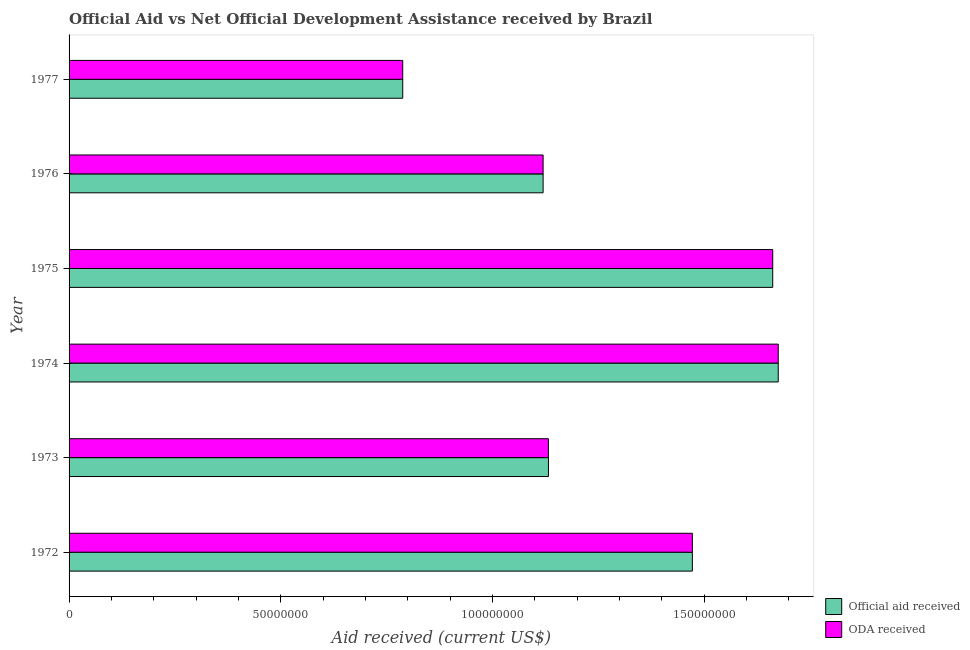How many groups of bars are there?
Provide a succinct answer. 6. Are the number of bars on each tick of the Y-axis equal?
Keep it short and to the point. Yes. How many bars are there on the 3rd tick from the bottom?
Keep it short and to the point. 2. In how many cases, is the number of bars for a given year not equal to the number of legend labels?
Your answer should be compact. 0. What is the official aid received in 1977?
Your answer should be very brief. 7.88e+07. Across all years, what is the maximum oda received?
Your answer should be compact. 1.67e+08. Across all years, what is the minimum official aid received?
Ensure brevity in your answer.  7.88e+07. In which year was the oda received maximum?
Give a very brief answer. 1974. What is the total oda received in the graph?
Offer a terse response. 7.85e+08. What is the difference between the oda received in 1972 and that in 1976?
Provide a succinct answer. 3.52e+07. What is the difference between the oda received in 1976 and the official aid received in 1974?
Offer a very short reply. -5.55e+07. What is the average official aid received per year?
Ensure brevity in your answer.  1.31e+08. What is the ratio of the official aid received in 1972 to that in 1977?
Keep it short and to the point. 1.87. Is the official aid received in 1974 less than that in 1975?
Provide a short and direct response. No. What is the difference between the highest and the second highest oda received?
Keep it short and to the point. 1.30e+06. What is the difference between the highest and the lowest official aid received?
Keep it short and to the point. 8.87e+07. In how many years, is the official aid received greater than the average official aid received taken over all years?
Make the answer very short. 3. What does the 2nd bar from the top in 1975 represents?
Give a very brief answer. Official aid received. What does the 1st bar from the bottom in 1973 represents?
Provide a short and direct response. Official aid received. How many bars are there?
Make the answer very short. 12. How many years are there in the graph?
Offer a terse response. 6. What is the difference between two consecutive major ticks on the X-axis?
Your response must be concise. 5.00e+07. Are the values on the major ticks of X-axis written in scientific E-notation?
Offer a terse response. No. Does the graph contain any zero values?
Your response must be concise. No. Where does the legend appear in the graph?
Offer a very short reply. Bottom right. How many legend labels are there?
Ensure brevity in your answer.  2. How are the legend labels stacked?
Offer a very short reply. Vertical. What is the title of the graph?
Ensure brevity in your answer.  Official Aid vs Net Official Development Assistance received by Brazil . What is the label or title of the X-axis?
Offer a terse response. Aid received (current US$). What is the Aid received (current US$) in Official aid received in 1972?
Your answer should be compact. 1.47e+08. What is the Aid received (current US$) in ODA received in 1972?
Your response must be concise. 1.47e+08. What is the Aid received (current US$) of Official aid received in 1973?
Offer a very short reply. 1.13e+08. What is the Aid received (current US$) of ODA received in 1973?
Provide a succinct answer. 1.13e+08. What is the Aid received (current US$) in Official aid received in 1974?
Provide a succinct answer. 1.67e+08. What is the Aid received (current US$) in ODA received in 1974?
Your response must be concise. 1.67e+08. What is the Aid received (current US$) of Official aid received in 1975?
Provide a succinct answer. 1.66e+08. What is the Aid received (current US$) in ODA received in 1975?
Keep it short and to the point. 1.66e+08. What is the Aid received (current US$) of Official aid received in 1976?
Your response must be concise. 1.12e+08. What is the Aid received (current US$) in ODA received in 1976?
Offer a very short reply. 1.12e+08. What is the Aid received (current US$) in Official aid received in 1977?
Keep it short and to the point. 7.88e+07. What is the Aid received (current US$) of ODA received in 1977?
Your answer should be compact. 7.88e+07. Across all years, what is the maximum Aid received (current US$) in Official aid received?
Give a very brief answer. 1.67e+08. Across all years, what is the maximum Aid received (current US$) in ODA received?
Your answer should be compact. 1.67e+08. Across all years, what is the minimum Aid received (current US$) in Official aid received?
Your response must be concise. 7.88e+07. Across all years, what is the minimum Aid received (current US$) of ODA received?
Ensure brevity in your answer.  7.88e+07. What is the total Aid received (current US$) in Official aid received in the graph?
Provide a succinct answer. 7.85e+08. What is the total Aid received (current US$) of ODA received in the graph?
Keep it short and to the point. 7.85e+08. What is the difference between the Aid received (current US$) of Official aid received in 1972 and that in 1973?
Ensure brevity in your answer.  3.40e+07. What is the difference between the Aid received (current US$) of ODA received in 1972 and that in 1973?
Make the answer very short. 3.40e+07. What is the difference between the Aid received (current US$) in Official aid received in 1972 and that in 1974?
Your answer should be compact. -2.03e+07. What is the difference between the Aid received (current US$) in ODA received in 1972 and that in 1974?
Offer a terse response. -2.03e+07. What is the difference between the Aid received (current US$) of Official aid received in 1972 and that in 1975?
Make the answer very short. -1.90e+07. What is the difference between the Aid received (current US$) in ODA received in 1972 and that in 1975?
Keep it short and to the point. -1.90e+07. What is the difference between the Aid received (current US$) in Official aid received in 1972 and that in 1976?
Provide a short and direct response. 3.52e+07. What is the difference between the Aid received (current US$) in ODA received in 1972 and that in 1976?
Provide a short and direct response. 3.52e+07. What is the difference between the Aid received (current US$) in Official aid received in 1972 and that in 1977?
Your response must be concise. 6.84e+07. What is the difference between the Aid received (current US$) in ODA received in 1972 and that in 1977?
Your answer should be very brief. 6.84e+07. What is the difference between the Aid received (current US$) in Official aid received in 1973 and that in 1974?
Your answer should be very brief. -5.43e+07. What is the difference between the Aid received (current US$) of ODA received in 1973 and that in 1974?
Offer a terse response. -5.43e+07. What is the difference between the Aid received (current US$) in Official aid received in 1973 and that in 1975?
Offer a very short reply. -5.30e+07. What is the difference between the Aid received (current US$) in ODA received in 1973 and that in 1975?
Provide a short and direct response. -5.30e+07. What is the difference between the Aid received (current US$) in Official aid received in 1973 and that in 1976?
Keep it short and to the point. 1.26e+06. What is the difference between the Aid received (current US$) of ODA received in 1973 and that in 1976?
Make the answer very short. 1.26e+06. What is the difference between the Aid received (current US$) in Official aid received in 1973 and that in 1977?
Your answer should be compact. 3.44e+07. What is the difference between the Aid received (current US$) in ODA received in 1973 and that in 1977?
Keep it short and to the point. 3.44e+07. What is the difference between the Aid received (current US$) of Official aid received in 1974 and that in 1975?
Offer a very short reply. 1.30e+06. What is the difference between the Aid received (current US$) in ODA received in 1974 and that in 1975?
Your answer should be very brief. 1.30e+06. What is the difference between the Aid received (current US$) of Official aid received in 1974 and that in 1976?
Your response must be concise. 5.55e+07. What is the difference between the Aid received (current US$) of ODA received in 1974 and that in 1976?
Make the answer very short. 5.55e+07. What is the difference between the Aid received (current US$) of Official aid received in 1974 and that in 1977?
Offer a very short reply. 8.87e+07. What is the difference between the Aid received (current US$) in ODA received in 1974 and that in 1977?
Keep it short and to the point. 8.87e+07. What is the difference between the Aid received (current US$) in Official aid received in 1975 and that in 1976?
Your response must be concise. 5.42e+07. What is the difference between the Aid received (current US$) in ODA received in 1975 and that in 1976?
Provide a short and direct response. 5.42e+07. What is the difference between the Aid received (current US$) of Official aid received in 1975 and that in 1977?
Give a very brief answer. 8.74e+07. What is the difference between the Aid received (current US$) of ODA received in 1975 and that in 1977?
Keep it short and to the point. 8.74e+07. What is the difference between the Aid received (current US$) in Official aid received in 1976 and that in 1977?
Offer a very short reply. 3.32e+07. What is the difference between the Aid received (current US$) of ODA received in 1976 and that in 1977?
Offer a terse response. 3.32e+07. What is the difference between the Aid received (current US$) in Official aid received in 1972 and the Aid received (current US$) in ODA received in 1973?
Give a very brief answer. 3.40e+07. What is the difference between the Aid received (current US$) in Official aid received in 1972 and the Aid received (current US$) in ODA received in 1974?
Offer a very short reply. -2.03e+07. What is the difference between the Aid received (current US$) in Official aid received in 1972 and the Aid received (current US$) in ODA received in 1975?
Your response must be concise. -1.90e+07. What is the difference between the Aid received (current US$) in Official aid received in 1972 and the Aid received (current US$) in ODA received in 1976?
Ensure brevity in your answer.  3.52e+07. What is the difference between the Aid received (current US$) of Official aid received in 1972 and the Aid received (current US$) of ODA received in 1977?
Provide a succinct answer. 6.84e+07. What is the difference between the Aid received (current US$) in Official aid received in 1973 and the Aid received (current US$) in ODA received in 1974?
Ensure brevity in your answer.  -5.43e+07. What is the difference between the Aid received (current US$) of Official aid received in 1973 and the Aid received (current US$) of ODA received in 1975?
Your answer should be very brief. -5.30e+07. What is the difference between the Aid received (current US$) of Official aid received in 1973 and the Aid received (current US$) of ODA received in 1976?
Ensure brevity in your answer.  1.26e+06. What is the difference between the Aid received (current US$) in Official aid received in 1973 and the Aid received (current US$) in ODA received in 1977?
Give a very brief answer. 3.44e+07. What is the difference between the Aid received (current US$) in Official aid received in 1974 and the Aid received (current US$) in ODA received in 1975?
Give a very brief answer. 1.30e+06. What is the difference between the Aid received (current US$) of Official aid received in 1974 and the Aid received (current US$) of ODA received in 1976?
Keep it short and to the point. 5.55e+07. What is the difference between the Aid received (current US$) of Official aid received in 1974 and the Aid received (current US$) of ODA received in 1977?
Ensure brevity in your answer.  8.87e+07. What is the difference between the Aid received (current US$) in Official aid received in 1975 and the Aid received (current US$) in ODA received in 1976?
Your answer should be very brief. 5.42e+07. What is the difference between the Aid received (current US$) of Official aid received in 1975 and the Aid received (current US$) of ODA received in 1977?
Give a very brief answer. 8.74e+07. What is the difference between the Aid received (current US$) in Official aid received in 1976 and the Aid received (current US$) in ODA received in 1977?
Keep it short and to the point. 3.32e+07. What is the average Aid received (current US$) of Official aid received per year?
Offer a terse response. 1.31e+08. What is the average Aid received (current US$) in ODA received per year?
Offer a very short reply. 1.31e+08. In the year 1973, what is the difference between the Aid received (current US$) in Official aid received and Aid received (current US$) in ODA received?
Ensure brevity in your answer.  0. In the year 1976, what is the difference between the Aid received (current US$) of Official aid received and Aid received (current US$) of ODA received?
Your response must be concise. 0. What is the ratio of the Aid received (current US$) in Official aid received in 1972 to that in 1973?
Your answer should be very brief. 1.3. What is the ratio of the Aid received (current US$) in ODA received in 1972 to that in 1973?
Offer a terse response. 1.3. What is the ratio of the Aid received (current US$) of Official aid received in 1972 to that in 1974?
Provide a short and direct response. 0.88. What is the ratio of the Aid received (current US$) in ODA received in 1972 to that in 1974?
Your response must be concise. 0.88. What is the ratio of the Aid received (current US$) of Official aid received in 1972 to that in 1975?
Your answer should be very brief. 0.89. What is the ratio of the Aid received (current US$) in ODA received in 1972 to that in 1975?
Provide a succinct answer. 0.89. What is the ratio of the Aid received (current US$) in Official aid received in 1972 to that in 1976?
Give a very brief answer. 1.31. What is the ratio of the Aid received (current US$) of ODA received in 1972 to that in 1976?
Offer a terse response. 1.31. What is the ratio of the Aid received (current US$) of Official aid received in 1972 to that in 1977?
Provide a short and direct response. 1.87. What is the ratio of the Aid received (current US$) in ODA received in 1972 to that in 1977?
Your response must be concise. 1.87. What is the ratio of the Aid received (current US$) in Official aid received in 1973 to that in 1974?
Make the answer very short. 0.68. What is the ratio of the Aid received (current US$) in ODA received in 1973 to that in 1974?
Give a very brief answer. 0.68. What is the ratio of the Aid received (current US$) in Official aid received in 1973 to that in 1975?
Provide a short and direct response. 0.68. What is the ratio of the Aid received (current US$) of ODA received in 1973 to that in 1975?
Offer a very short reply. 0.68. What is the ratio of the Aid received (current US$) in Official aid received in 1973 to that in 1976?
Keep it short and to the point. 1.01. What is the ratio of the Aid received (current US$) in ODA received in 1973 to that in 1976?
Ensure brevity in your answer.  1.01. What is the ratio of the Aid received (current US$) in Official aid received in 1973 to that in 1977?
Your answer should be compact. 1.44. What is the ratio of the Aid received (current US$) of ODA received in 1973 to that in 1977?
Provide a short and direct response. 1.44. What is the ratio of the Aid received (current US$) in Official aid received in 1974 to that in 1975?
Keep it short and to the point. 1.01. What is the ratio of the Aid received (current US$) in ODA received in 1974 to that in 1975?
Ensure brevity in your answer.  1.01. What is the ratio of the Aid received (current US$) in Official aid received in 1974 to that in 1976?
Offer a terse response. 1.5. What is the ratio of the Aid received (current US$) in ODA received in 1974 to that in 1976?
Ensure brevity in your answer.  1.5. What is the ratio of the Aid received (current US$) of Official aid received in 1974 to that in 1977?
Keep it short and to the point. 2.13. What is the ratio of the Aid received (current US$) in ODA received in 1974 to that in 1977?
Give a very brief answer. 2.13. What is the ratio of the Aid received (current US$) of Official aid received in 1975 to that in 1976?
Keep it short and to the point. 1.48. What is the ratio of the Aid received (current US$) of ODA received in 1975 to that in 1976?
Keep it short and to the point. 1.48. What is the ratio of the Aid received (current US$) of Official aid received in 1975 to that in 1977?
Make the answer very short. 2.11. What is the ratio of the Aid received (current US$) in ODA received in 1975 to that in 1977?
Your response must be concise. 2.11. What is the ratio of the Aid received (current US$) of Official aid received in 1976 to that in 1977?
Ensure brevity in your answer.  1.42. What is the ratio of the Aid received (current US$) in ODA received in 1976 to that in 1977?
Offer a very short reply. 1.42. What is the difference between the highest and the second highest Aid received (current US$) of Official aid received?
Give a very brief answer. 1.30e+06. What is the difference between the highest and the second highest Aid received (current US$) of ODA received?
Provide a succinct answer. 1.30e+06. What is the difference between the highest and the lowest Aid received (current US$) of Official aid received?
Ensure brevity in your answer.  8.87e+07. What is the difference between the highest and the lowest Aid received (current US$) of ODA received?
Give a very brief answer. 8.87e+07. 